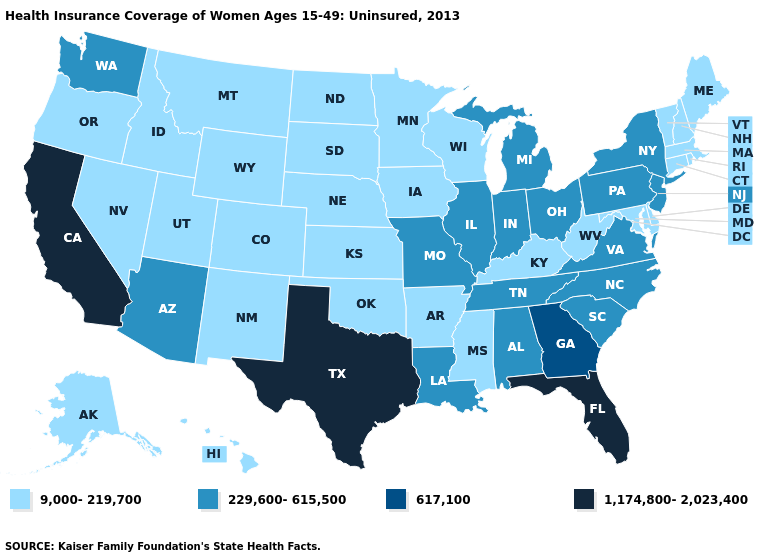What is the value of Arkansas?
Keep it brief. 9,000-219,700. Name the states that have a value in the range 9,000-219,700?
Quick response, please. Alaska, Arkansas, Colorado, Connecticut, Delaware, Hawaii, Idaho, Iowa, Kansas, Kentucky, Maine, Maryland, Massachusetts, Minnesota, Mississippi, Montana, Nebraska, Nevada, New Hampshire, New Mexico, North Dakota, Oklahoma, Oregon, Rhode Island, South Dakota, Utah, Vermont, West Virginia, Wisconsin, Wyoming. Among the states that border Connecticut , does New York have the highest value?
Be succinct. Yes. Does Virginia have the same value as Montana?
Be succinct. No. What is the lowest value in states that border California?
Give a very brief answer. 9,000-219,700. What is the highest value in the USA?
Keep it brief. 1,174,800-2,023,400. What is the value of New Hampshire?
Keep it brief. 9,000-219,700. Among the states that border Mississippi , does Louisiana have the highest value?
Concise answer only. Yes. Does the map have missing data?
Answer briefly. No. Which states have the lowest value in the MidWest?
Write a very short answer. Iowa, Kansas, Minnesota, Nebraska, North Dakota, South Dakota, Wisconsin. Does Florida have the highest value in the USA?
Write a very short answer. Yes. Does the map have missing data?
Write a very short answer. No. What is the lowest value in the USA?
Be succinct. 9,000-219,700. Name the states that have a value in the range 617,100?
Keep it brief. Georgia. Which states have the highest value in the USA?
Keep it brief. California, Florida, Texas. 